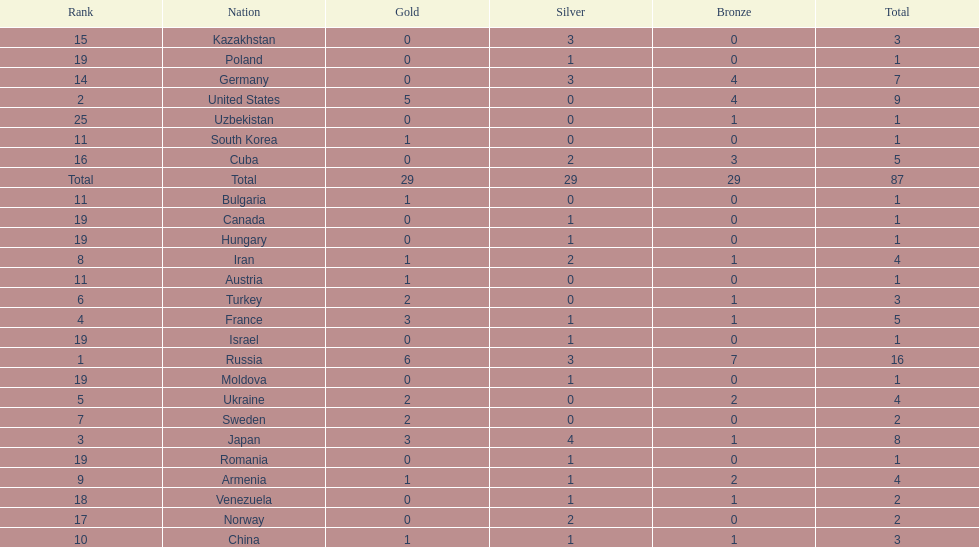Could you parse the entire table? {'header': ['Rank', 'Nation', 'Gold', 'Silver', 'Bronze', 'Total'], 'rows': [['15', 'Kazakhstan', '0', '3', '0', '3'], ['19', 'Poland', '0', '1', '0', '1'], ['14', 'Germany', '0', '3', '4', '7'], ['2', 'United States', '5', '0', '4', '9'], ['25', 'Uzbekistan', '0', '0', '1', '1'], ['11', 'South Korea', '1', '0', '0', '1'], ['16', 'Cuba', '0', '2', '3', '5'], ['Total', 'Total', '29', '29', '29', '87'], ['11', 'Bulgaria', '1', '0', '0', '1'], ['19', 'Canada', '0', '1', '0', '1'], ['19', 'Hungary', '0', '1', '0', '1'], ['8', 'Iran', '1', '2', '1', '4'], ['11', 'Austria', '1', '0', '0', '1'], ['6', 'Turkey', '2', '0', '1', '3'], ['4', 'France', '3', '1', '1', '5'], ['19', 'Israel', '0', '1', '0', '1'], ['1', 'Russia', '6', '3', '7', '16'], ['19', 'Moldova', '0', '1', '0', '1'], ['5', 'Ukraine', '2', '0', '2', '4'], ['7', 'Sweden', '2', '0', '0', '2'], ['3', 'Japan', '3', '4', '1', '8'], ['19', 'Romania', '0', '1', '0', '1'], ['9', 'Armenia', '1', '1', '2', '4'], ['18', 'Venezuela', '0', '1', '1', '2'], ['17', 'Norway', '0', '2', '0', '2'], ['10', 'China', '1', '1', '1', '3']]} Which nation has one gold medal but zero in both silver and bronze? Austria. 